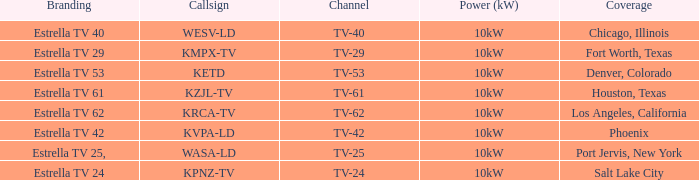List the branding name for channel tv-62. Estrella TV 62. 